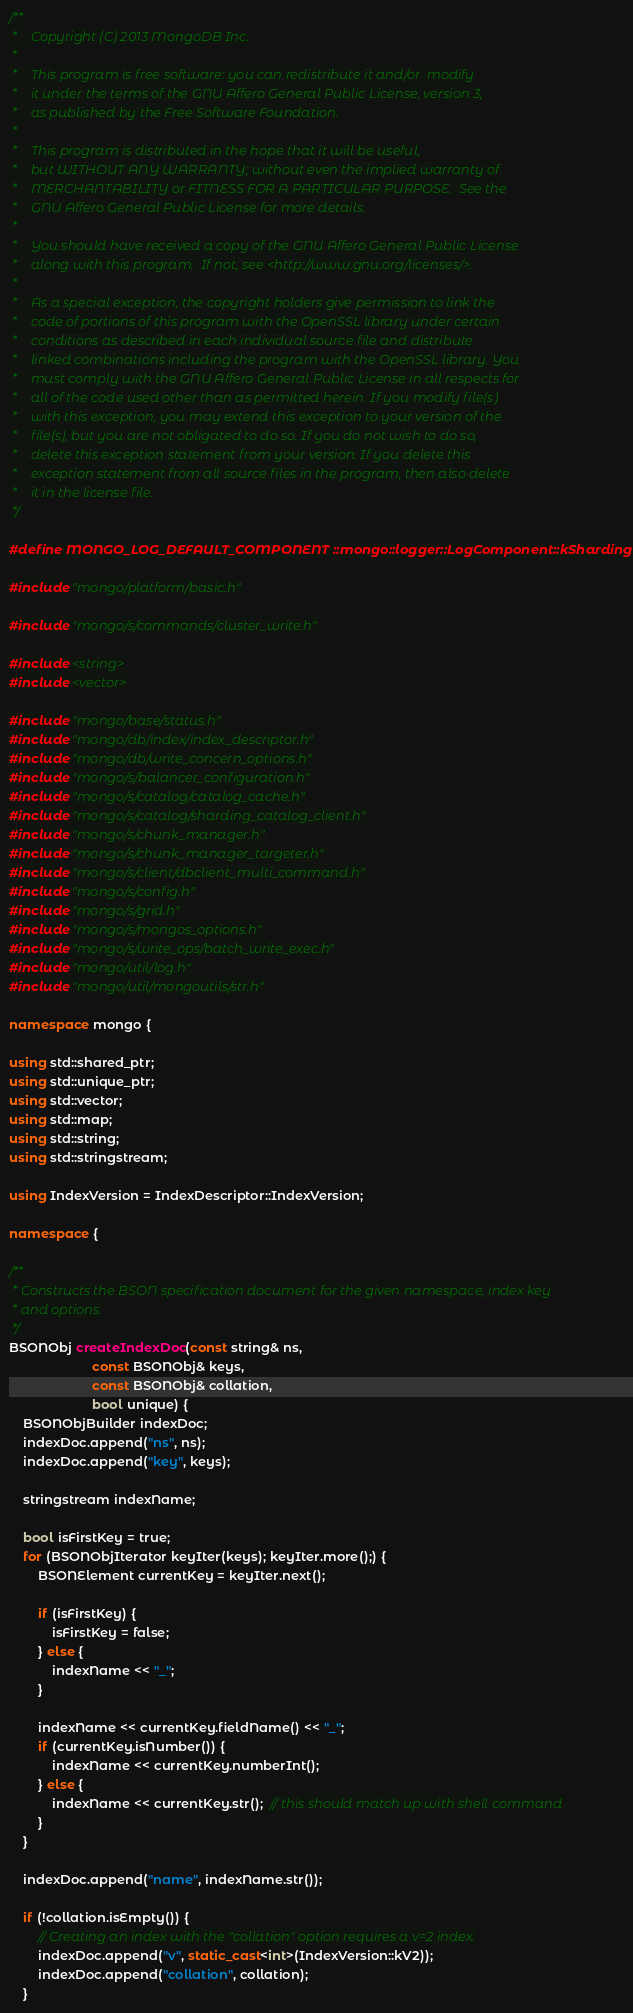Convert code to text. <code><loc_0><loc_0><loc_500><loc_500><_C++_>/**
 *    Copyright (C) 2013 MongoDB Inc.
 *
 *    This program is free software: you can redistribute it and/or  modify
 *    it under the terms of the GNU Affero General Public License, version 3,
 *    as published by the Free Software Foundation.
 *
 *    This program is distributed in the hope that it will be useful,
 *    but WITHOUT ANY WARRANTY; without even the implied warranty of
 *    MERCHANTABILITY or FITNESS FOR A PARTICULAR PURPOSE.  See the
 *    GNU Affero General Public License for more details.
 *
 *    You should have received a copy of the GNU Affero General Public License
 *    along with this program.  If not, see <http://www.gnu.org/licenses/>.
 *
 *    As a special exception, the copyright holders give permission to link the
 *    code of portions of this program with the OpenSSL library under certain
 *    conditions as described in each individual source file and distribute
 *    linked combinations including the program with the OpenSSL library. You
 *    must comply with the GNU Affero General Public License in all respects for
 *    all of the code used other than as permitted herein. If you modify file(s)
 *    with this exception, you may extend this exception to your version of the
 *    file(s), but you are not obligated to do so. If you do not wish to do so,
 *    delete this exception statement from your version. If you delete this
 *    exception statement from all source files in the program, then also delete
 *    it in the license file.
 */

#define MONGO_LOG_DEFAULT_COMPONENT ::mongo::logger::LogComponent::kSharding

#include "mongo/platform/basic.h"

#include "mongo/s/commands/cluster_write.h"

#include <string>
#include <vector>

#include "mongo/base/status.h"
#include "mongo/db/index/index_descriptor.h"
#include "mongo/db/write_concern_options.h"
#include "mongo/s/balancer_configuration.h"
#include "mongo/s/catalog/catalog_cache.h"
#include "mongo/s/catalog/sharding_catalog_client.h"
#include "mongo/s/chunk_manager.h"
#include "mongo/s/chunk_manager_targeter.h"
#include "mongo/s/client/dbclient_multi_command.h"
#include "mongo/s/config.h"
#include "mongo/s/grid.h"
#include "mongo/s/mongos_options.h"
#include "mongo/s/write_ops/batch_write_exec.h"
#include "mongo/util/log.h"
#include "mongo/util/mongoutils/str.h"

namespace mongo {

using std::shared_ptr;
using std::unique_ptr;
using std::vector;
using std::map;
using std::string;
using std::stringstream;

using IndexVersion = IndexDescriptor::IndexVersion;

namespace {

/**
 * Constructs the BSON specification document for the given namespace, index key
 * and options.
 */
BSONObj createIndexDoc(const string& ns,
                       const BSONObj& keys,
                       const BSONObj& collation,
                       bool unique) {
    BSONObjBuilder indexDoc;
    indexDoc.append("ns", ns);
    indexDoc.append("key", keys);

    stringstream indexName;

    bool isFirstKey = true;
    for (BSONObjIterator keyIter(keys); keyIter.more();) {
        BSONElement currentKey = keyIter.next();

        if (isFirstKey) {
            isFirstKey = false;
        } else {
            indexName << "_";
        }

        indexName << currentKey.fieldName() << "_";
        if (currentKey.isNumber()) {
            indexName << currentKey.numberInt();
        } else {
            indexName << currentKey.str();  // this should match up with shell command
        }
    }

    indexDoc.append("name", indexName.str());

    if (!collation.isEmpty()) {
        // Creating an index with the "collation" option requires a v=2 index.
        indexDoc.append("v", static_cast<int>(IndexVersion::kV2));
        indexDoc.append("collation", collation);
    }
</code> 